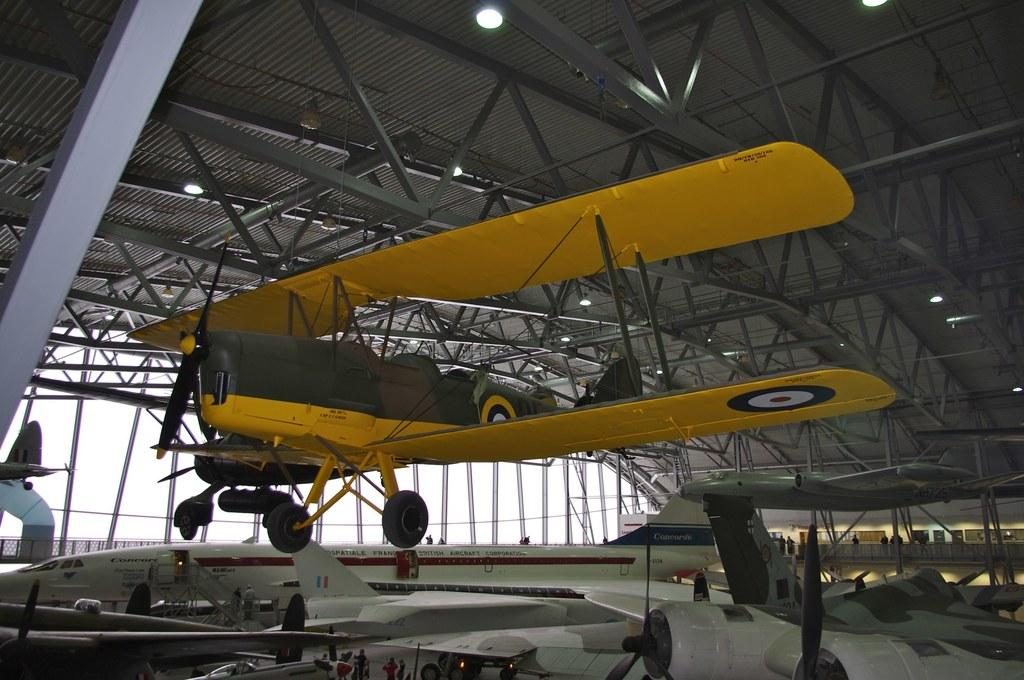What is the main subject of the image? The main subject of the image is aircraft. What other objects can be seen in the image? There are poles and lights visible in the image. How would you describe the sky in the background? The sky in the background appears to be white. Can you see a boot being used to plough the field in the image? No, there is no boot or field present in the image. 